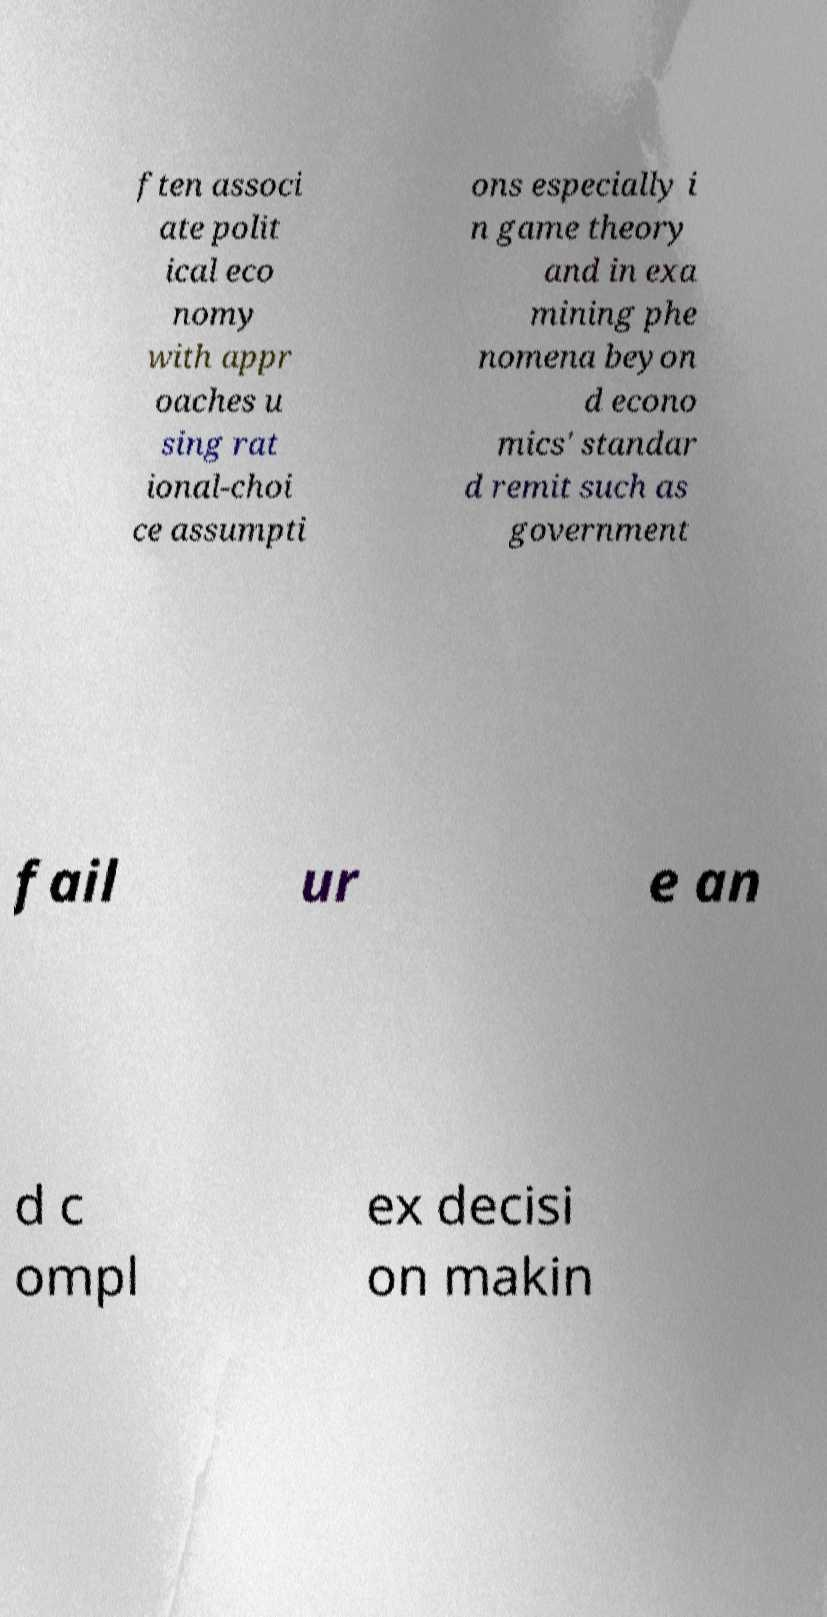Can you accurately transcribe the text from the provided image for me? ften associ ate polit ical eco nomy with appr oaches u sing rat ional-choi ce assumpti ons especially i n game theory and in exa mining phe nomena beyon d econo mics' standar d remit such as government fail ur e an d c ompl ex decisi on makin 